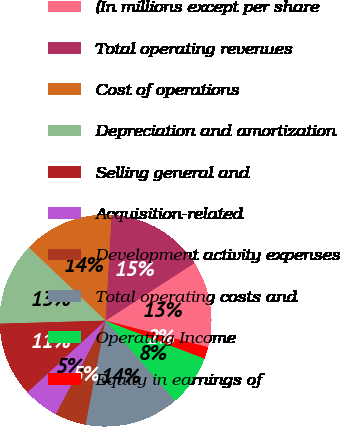Convert chart. <chart><loc_0><loc_0><loc_500><loc_500><pie_chart><fcel>(In millions except per share<fcel>Total operating revenues<fcel>Cost of operations<fcel>Depreciation and amortization<fcel>Selling general and<fcel>Acquisition-related<fcel>Development activity expenses<fcel>Total operating costs and<fcel>Operating Income<fcel>Equity in earnings of<nl><fcel>13.17%<fcel>14.97%<fcel>13.77%<fcel>12.57%<fcel>11.38%<fcel>5.39%<fcel>4.79%<fcel>14.37%<fcel>7.78%<fcel>1.8%<nl></chart> 